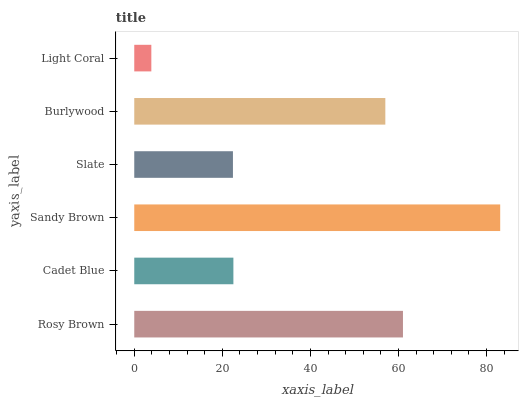Is Light Coral the minimum?
Answer yes or no. Yes. Is Sandy Brown the maximum?
Answer yes or no. Yes. Is Cadet Blue the minimum?
Answer yes or no. No. Is Cadet Blue the maximum?
Answer yes or no. No. Is Rosy Brown greater than Cadet Blue?
Answer yes or no. Yes. Is Cadet Blue less than Rosy Brown?
Answer yes or no. Yes. Is Cadet Blue greater than Rosy Brown?
Answer yes or no. No. Is Rosy Brown less than Cadet Blue?
Answer yes or no. No. Is Burlywood the high median?
Answer yes or no. Yes. Is Cadet Blue the low median?
Answer yes or no. Yes. Is Cadet Blue the high median?
Answer yes or no. No. Is Rosy Brown the low median?
Answer yes or no. No. 